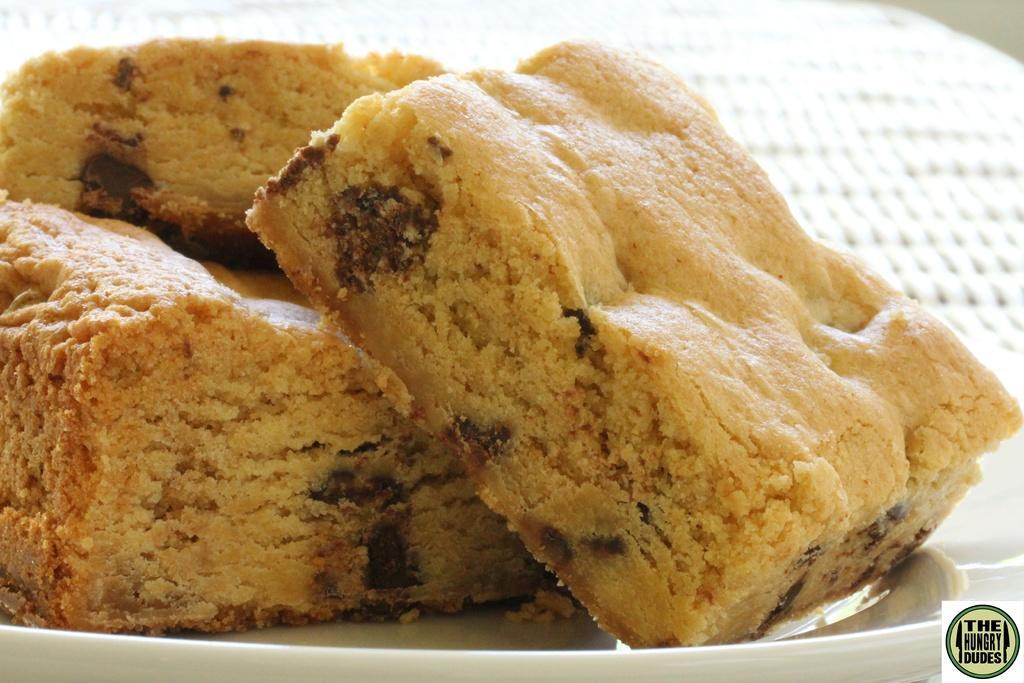In one or two sentences, can you explain what this image depicts? In this picture we can see food items in a plate, in the bottom right we can see a logo on it. 